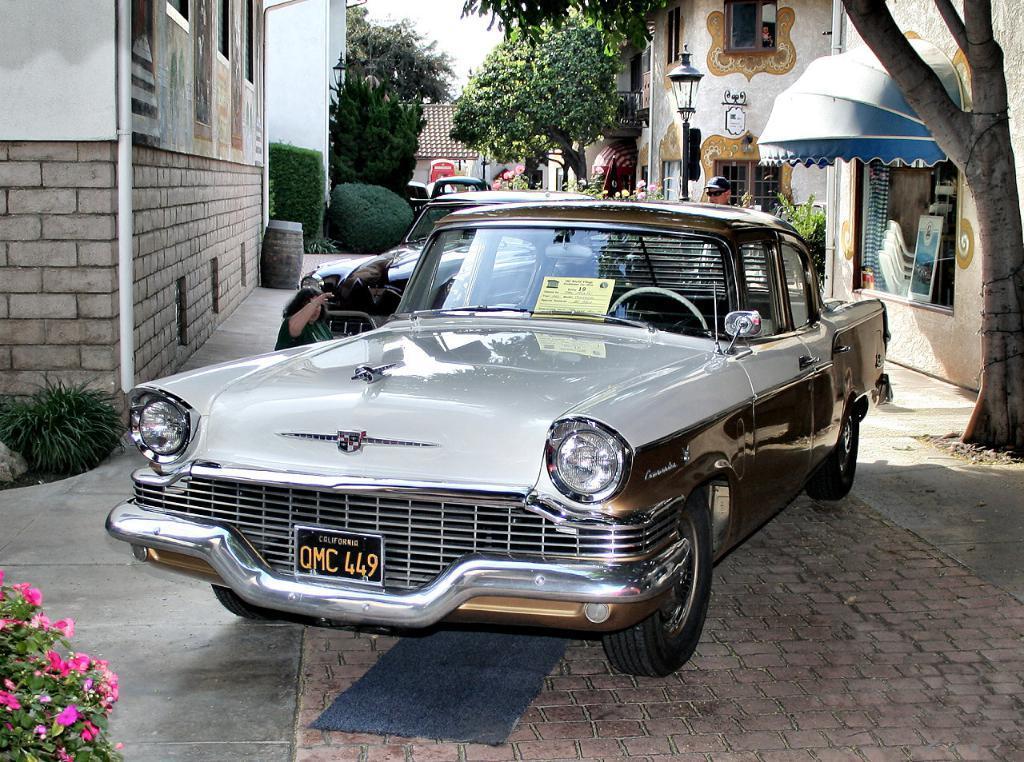Describe this image in one or two sentences. In this image we can see a few vehicles, there are some buildings, poles, lights, trees, plants, chairs and persons, in the background, we can see the sky. 